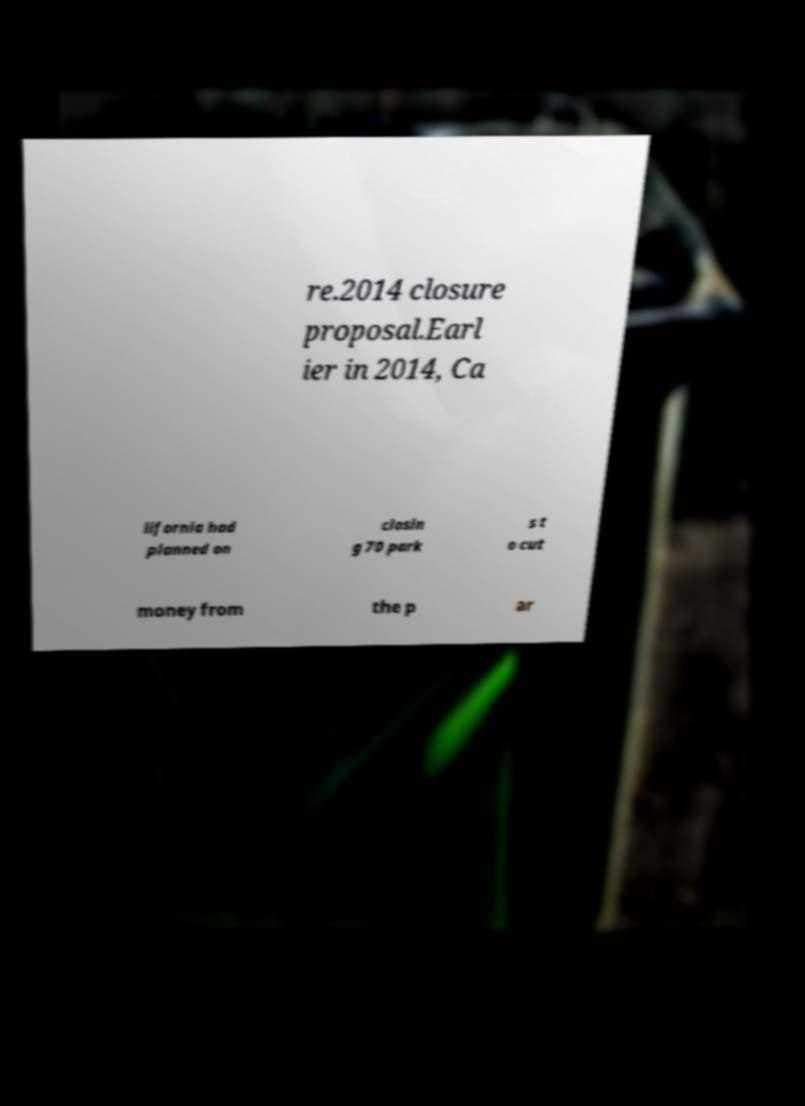Could you assist in decoding the text presented in this image and type it out clearly? re.2014 closure proposal.Earl ier in 2014, Ca lifornia had planned on closin g 70 park s t o cut money from the p ar 